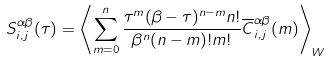Convert formula to latex. <formula><loc_0><loc_0><loc_500><loc_500>S ^ { \alpha \beta } _ { i , j } ( \tau ) = \left \langle \sum _ { m = 0 } ^ { n } \frac { \tau ^ { m } ( \beta - \tau ) ^ { n - m } n ! } { \beta ^ { n } ( n - m ) ! m ! } \overline { C } ^ { \alpha \beta } _ { i , j } ( m ) \right \rangle _ { W } \,</formula> 